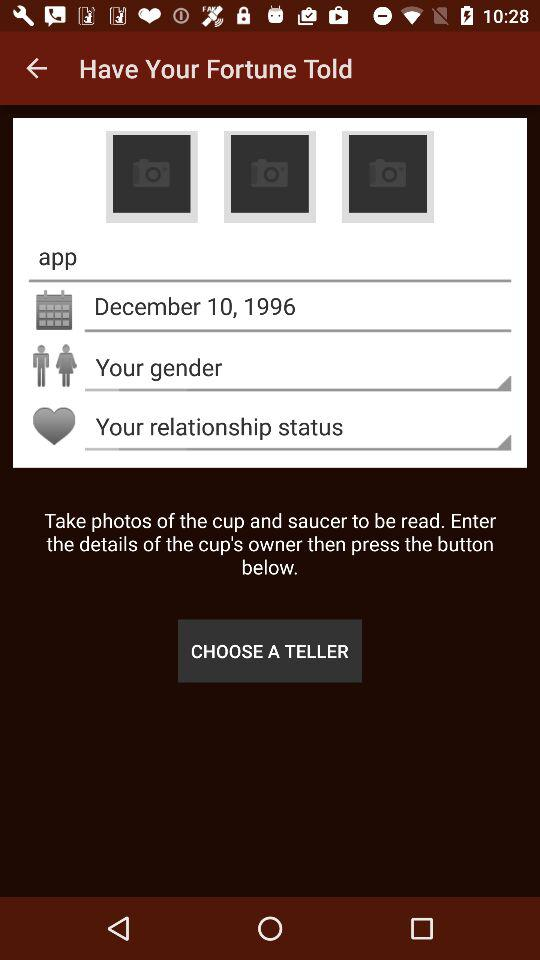How many input fields are there for the cup's owner?
Answer the question using a single word or phrase. 3 